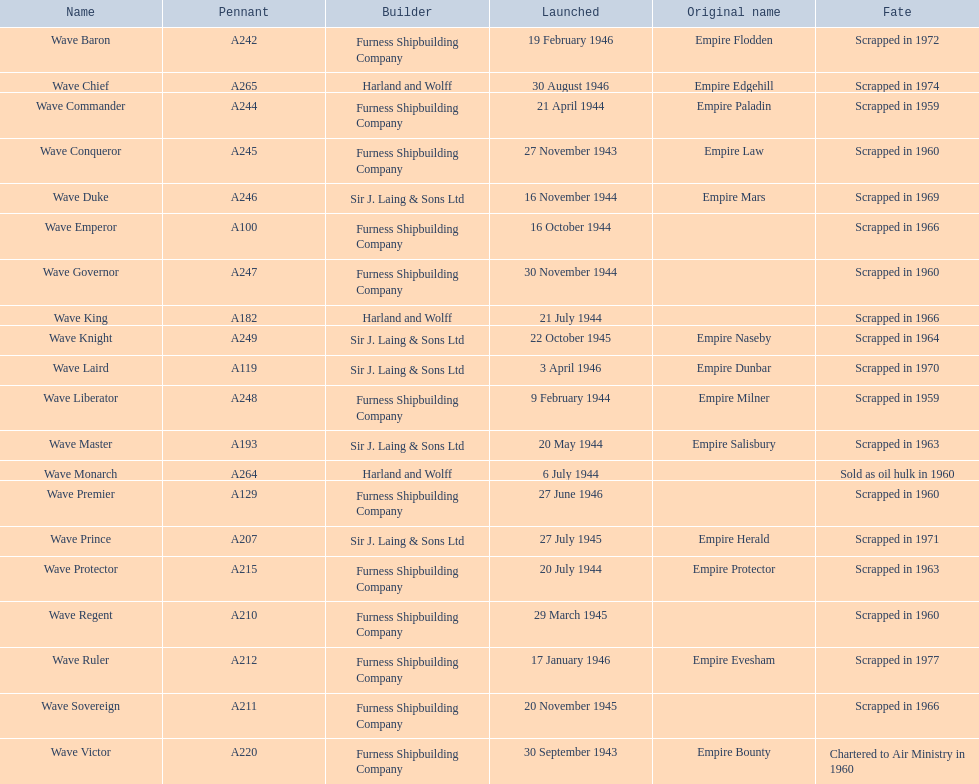What was the launch year of the wave victor? 30 September 1943. What other boat was introduced in 1943? Wave Conqueror. 